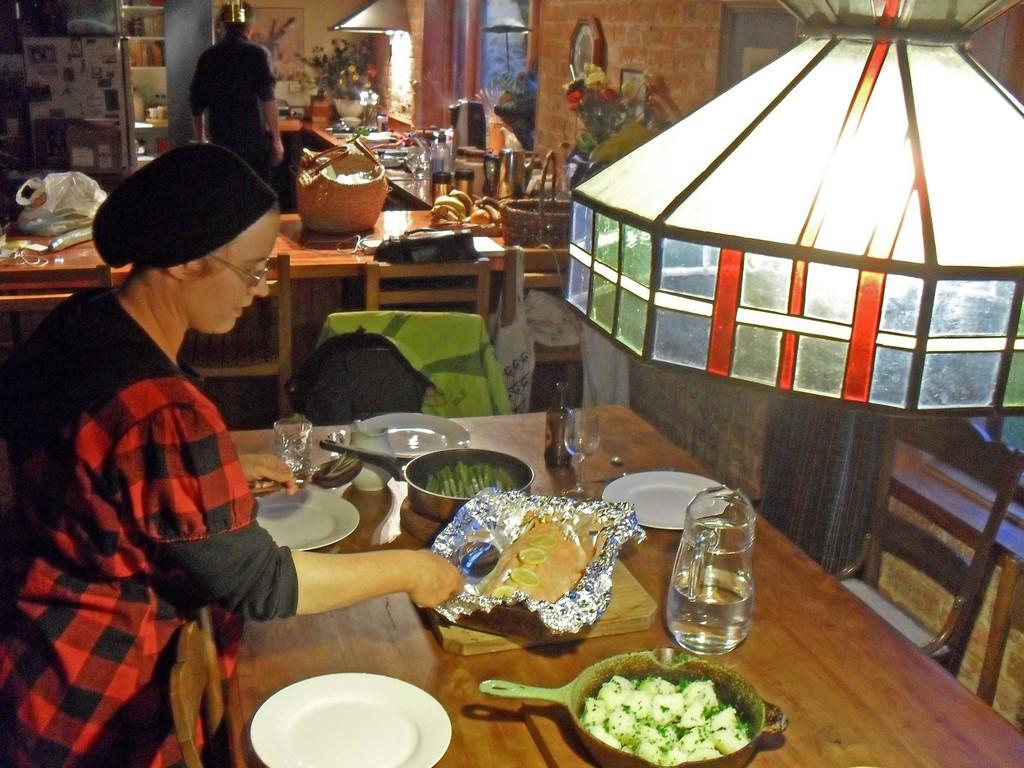What is the person near the table doing? There is a person standing near the table, but their activity is not specified in the facts. What objects are on the table? There are plates, glasses, pans with food, and a jar on the table. What might be used for drinking in the image? The glasses on the table might be used for drinking. What is being served on the table? The pans with food on the table suggest that food is being served. What type of birthday celebration is happening in the image? There is no mention of a birthday celebration in the image or the provided facts. Can you tell me how many toads are visible in the image? There are no toads present in the image. 